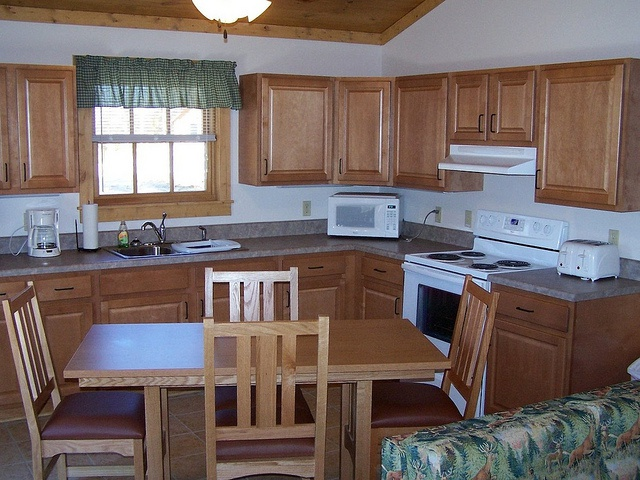Describe the objects in this image and their specific colors. I can see dining table in maroon, gray, and lightblue tones, chair in maroon, gray, and black tones, couch in maroon, gray, black, purple, and darkgray tones, chair in maroon, black, gray, and darkgray tones, and oven in maroon, darkgray, black, and lightblue tones in this image. 